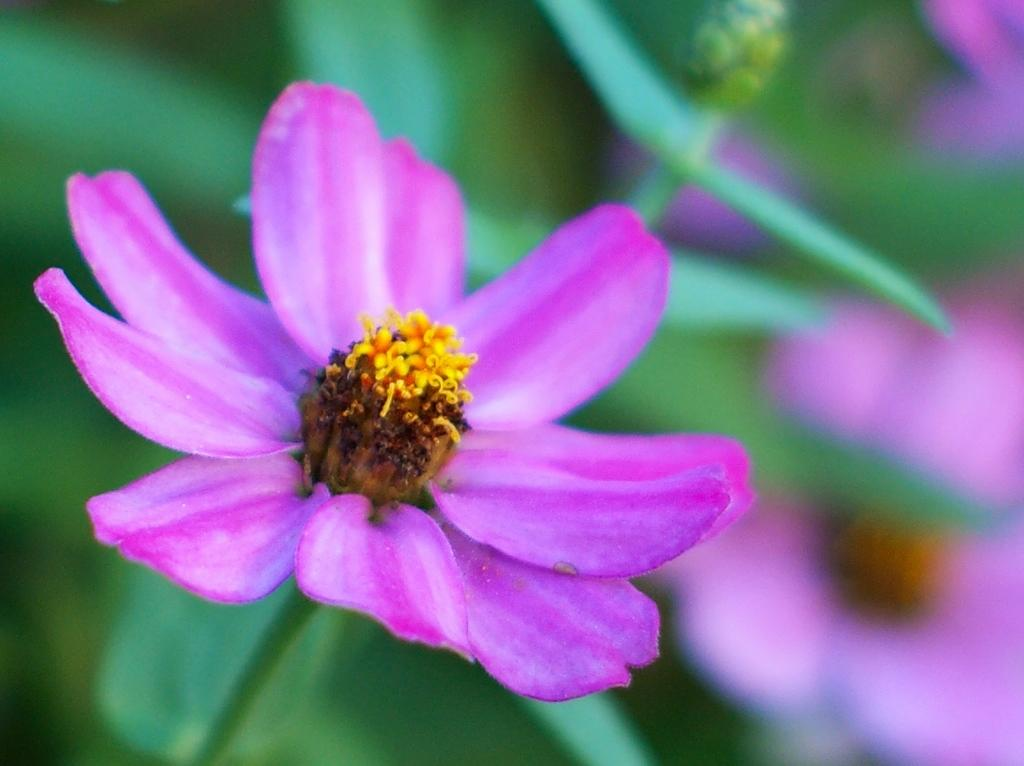What is the main subject of the image? There is a flower in the image. Can you describe the colors of the flower? The flower has pink and yellow colors. What else can be seen in the background of the image? There are leaves in the background of the image. What color are the leaves? The leaves have a green color. What is the grandfather doing with the worm in the image? There is no grandfather or worm present in the image; it only features a flower and leaves. 